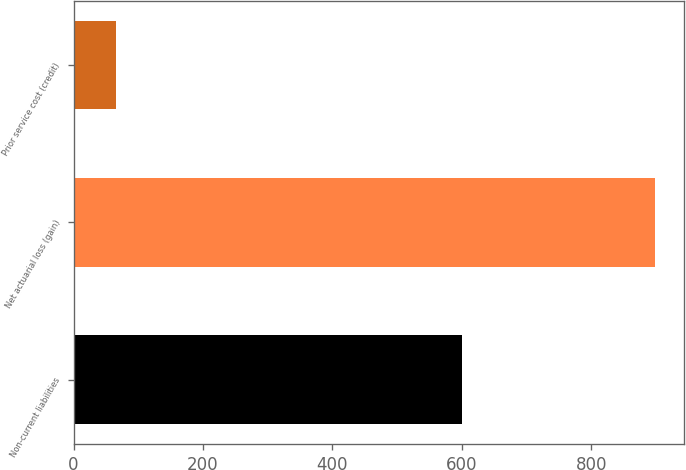<chart> <loc_0><loc_0><loc_500><loc_500><bar_chart><fcel>Non-current liabilities<fcel>Net actuarial loss (gain)<fcel>Prior service cost (credit)<nl><fcel>601<fcel>899<fcel>65<nl></chart> 